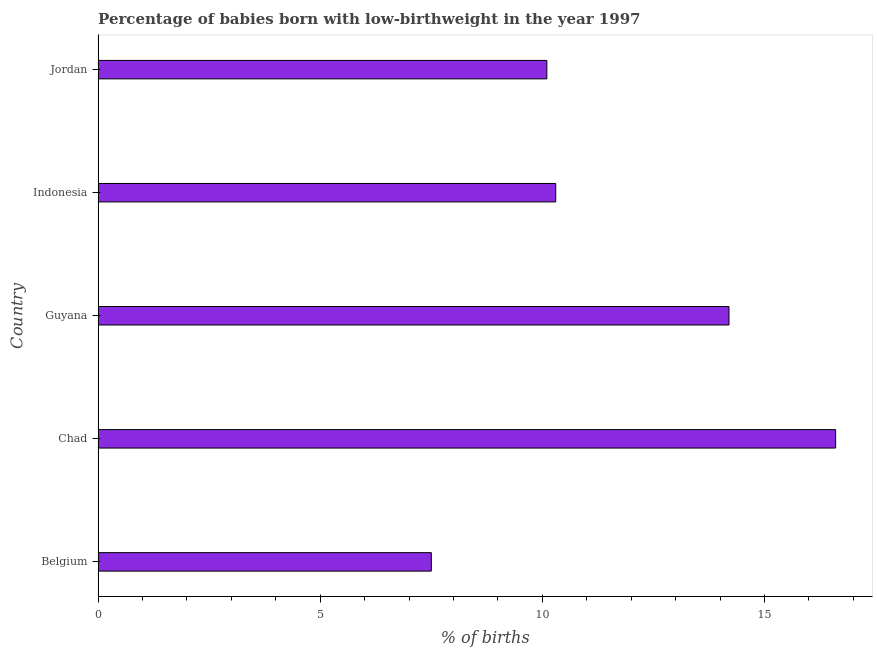What is the title of the graph?
Provide a succinct answer. Percentage of babies born with low-birthweight in the year 1997. What is the label or title of the X-axis?
Make the answer very short. % of births. What is the label or title of the Y-axis?
Offer a terse response. Country. What is the percentage of babies who were born with low-birthweight in Jordan?
Keep it short and to the point. 10.1. Across all countries, what is the minimum percentage of babies who were born with low-birthweight?
Keep it short and to the point. 7.5. In which country was the percentage of babies who were born with low-birthweight maximum?
Keep it short and to the point. Chad. What is the sum of the percentage of babies who were born with low-birthweight?
Offer a very short reply. 58.7. What is the difference between the percentage of babies who were born with low-birthweight in Belgium and Jordan?
Your response must be concise. -2.6. What is the average percentage of babies who were born with low-birthweight per country?
Ensure brevity in your answer.  11.74. In how many countries, is the percentage of babies who were born with low-birthweight greater than 5 %?
Ensure brevity in your answer.  5. What is the ratio of the percentage of babies who were born with low-birthweight in Chad to that in Guyana?
Your answer should be compact. 1.17. What is the difference between the highest and the second highest percentage of babies who were born with low-birthweight?
Your response must be concise. 2.4. What is the difference between the highest and the lowest percentage of babies who were born with low-birthweight?
Give a very brief answer. 9.1. Are all the bars in the graph horizontal?
Provide a short and direct response. Yes. What is the difference between two consecutive major ticks on the X-axis?
Provide a succinct answer. 5. Are the values on the major ticks of X-axis written in scientific E-notation?
Your response must be concise. No. What is the % of births in Belgium?
Make the answer very short. 7.5. What is the % of births in Indonesia?
Offer a very short reply. 10.3. What is the difference between the % of births in Belgium and Indonesia?
Your response must be concise. -2.8. What is the difference between the % of births in Guyana and Indonesia?
Ensure brevity in your answer.  3.9. What is the difference between the % of births in Indonesia and Jordan?
Give a very brief answer. 0.2. What is the ratio of the % of births in Belgium to that in Chad?
Provide a short and direct response. 0.45. What is the ratio of the % of births in Belgium to that in Guyana?
Provide a short and direct response. 0.53. What is the ratio of the % of births in Belgium to that in Indonesia?
Offer a very short reply. 0.73. What is the ratio of the % of births in Belgium to that in Jordan?
Keep it short and to the point. 0.74. What is the ratio of the % of births in Chad to that in Guyana?
Your answer should be compact. 1.17. What is the ratio of the % of births in Chad to that in Indonesia?
Make the answer very short. 1.61. What is the ratio of the % of births in Chad to that in Jordan?
Give a very brief answer. 1.64. What is the ratio of the % of births in Guyana to that in Indonesia?
Make the answer very short. 1.38. What is the ratio of the % of births in Guyana to that in Jordan?
Your answer should be compact. 1.41. What is the ratio of the % of births in Indonesia to that in Jordan?
Provide a succinct answer. 1.02. 